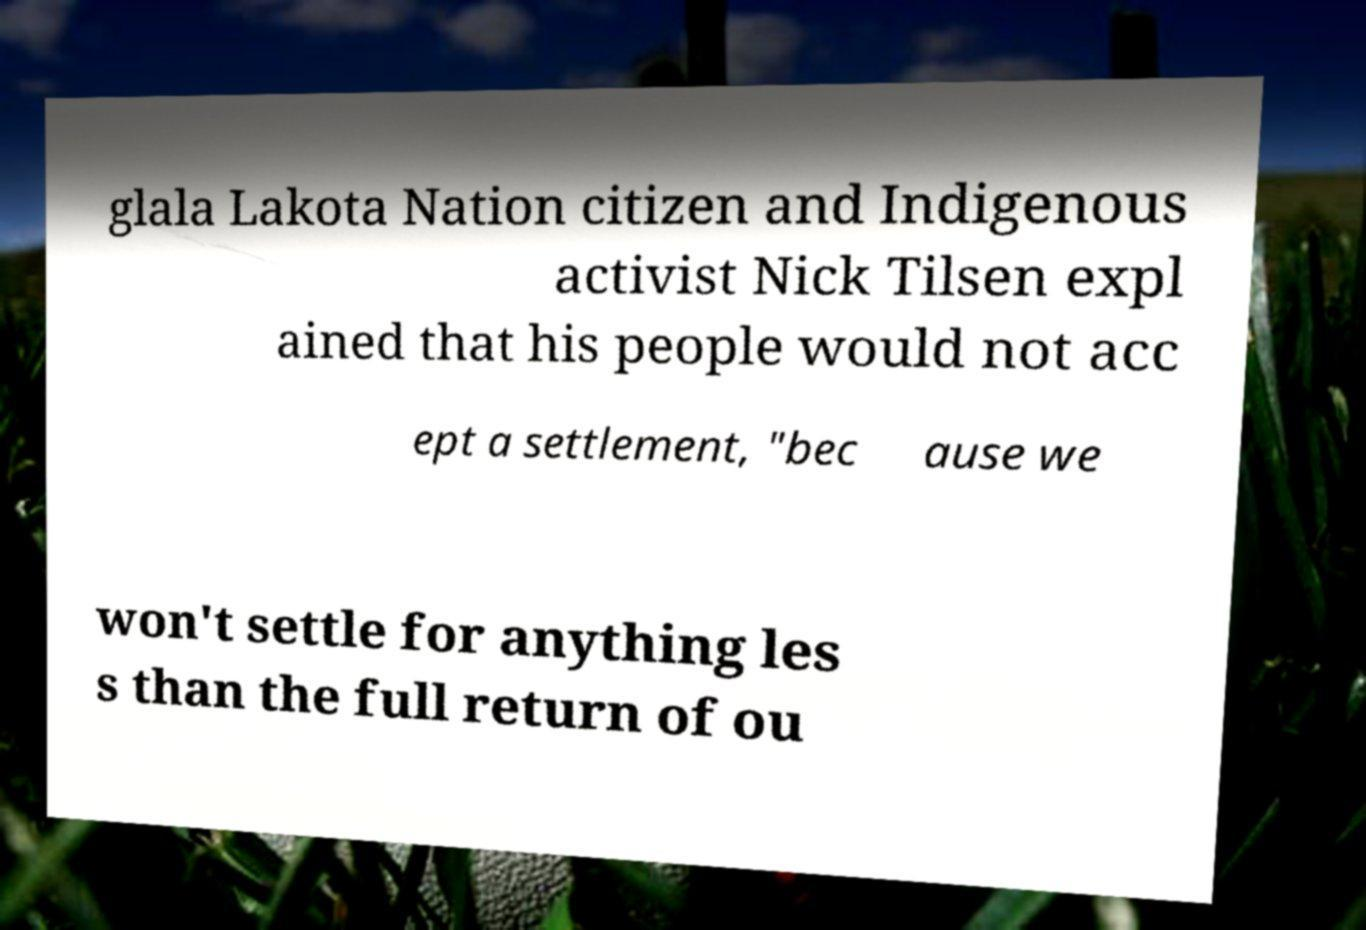Can you accurately transcribe the text from the provided image for me? glala Lakota Nation citizen and Indigenous activist Nick Tilsen expl ained that his people would not acc ept a settlement, "bec ause we won't settle for anything les s than the full return of ou 